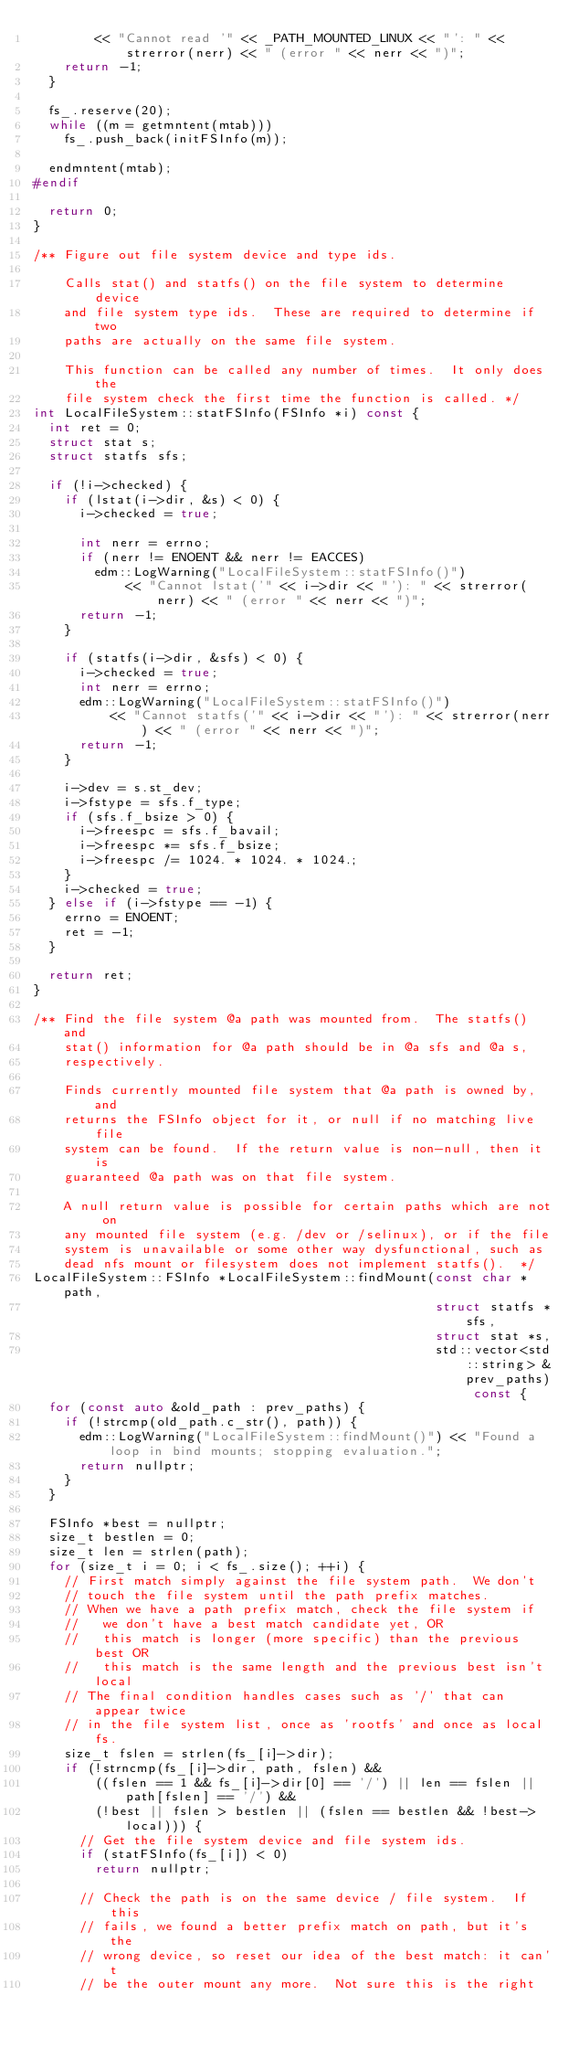Convert code to text. <code><loc_0><loc_0><loc_500><loc_500><_C++_>        << "Cannot read '" << _PATH_MOUNTED_LINUX << "': " << strerror(nerr) << " (error " << nerr << ")";
    return -1;
  }

  fs_.reserve(20);
  while ((m = getmntent(mtab)))
    fs_.push_back(initFSInfo(m));

  endmntent(mtab);
#endif

  return 0;
}

/** Figure out file system device and type ids.

    Calls stat() and statfs() on the file system to determine device
    and file system type ids.  These are required to determine if two
    paths are actually on the same file system.

    This function can be called any number of times.  It only does the
    file system check the first time the function is called. */
int LocalFileSystem::statFSInfo(FSInfo *i) const {
  int ret = 0;
  struct stat s;
  struct statfs sfs;

  if (!i->checked) {
    if (lstat(i->dir, &s) < 0) {
      i->checked = true;

      int nerr = errno;
      if (nerr != ENOENT && nerr != EACCES)
        edm::LogWarning("LocalFileSystem::statFSInfo()")
            << "Cannot lstat('" << i->dir << "'): " << strerror(nerr) << " (error " << nerr << ")";
      return -1;
    }

    if (statfs(i->dir, &sfs) < 0) {
      i->checked = true;
      int nerr = errno;
      edm::LogWarning("LocalFileSystem::statFSInfo()")
          << "Cannot statfs('" << i->dir << "'): " << strerror(nerr) << " (error " << nerr << ")";
      return -1;
    }

    i->dev = s.st_dev;
    i->fstype = sfs.f_type;
    if (sfs.f_bsize > 0) {
      i->freespc = sfs.f_bavail;
      i->freespc *= sfs.f_bsize;
      i->freespc /= 1024. * 1024. * 1024.;
    }
    i->checked = true;
  } else if (i->fstype == -1) {
    errno = ENOENT;
    ret = -1;
  }

  return ret;
}

/** Find the file system @a path was mounted from.  The statfs() and
    stat() information for @a path should be in @a sfs and @a s,
    respectively.

    Finds currently mounted file system that @a path is owned by, and
    returns the FSInfo object for it, or null if no matching live file
    system can be found.  If the return value is non-null, then it is
    guaranteed @a path was on that file system.

    A null return value is possible for certain paths which are not on
    any mounted file system (e.g. /dev or /selinux), or if the file
    system is unavailable or some other way dysfunctional, such as
    dead nfs mount or filesystem does not implement statfs().  */
LocalFileSystem::FSInfo *LocalFileSystem::findMount(const char *path,
                                                    struct statfs *sfs,
                                                    struct stat *s,
                                                    std::vector<std::string> &prev_paths) const {
  for (const auto &old_path : prev_paths) {
    if (!strcmp(old_path.c_str(), path)) {
      edm::LogWarning("LocalFileSystem::findMount()") << "Found a loop in bind mounts; stopping evaluation.";
      return nullptr;
    }
  }

  FSInfo *best = nullptr;
  size_t bestlen = 0;
  size_t len = strlen(path);
  for (size_t i = 0; i < fs_.size(); ++i) {
    // First match simply against the file system path.  We don't
    // touch the file system until the path prefix matches.
    // When we have a path prefix match, check the file system if
    //   we don't have a best match candidate yet, OR
    //   this match is longer (more specific) than the previous best OR
    //   this match is the same length and the previous best isn't local
    // The final condition handles cases such as '/' that can appear twice
    // in the file system list, once as 'rootfs' and once as local fs.
    size_t fslen = strlen(fs_[i]->dir);
    if (!strncmp(fs_[i]->dir, path, fslen) &&
        ((fslen == 1 && fs_[i]->dir[0] == '/') || len == fslen || path[fslen] == '/') &&
        (!best || fslen > bestlen || (fslen == bestlen && !best->local))) {
      // Get the file system device and file system ids.
      if (statFSInfo(fs_[i]) < 0)
        return nullptr;

      // Check the path is on the same device / file system.  If this
      // fails, we found a better prefix match on path, but it's the
      // wrong device, so reset our idea of the best match: it can't
      // be the outer mount any more.  Not sure this is the right</code> 